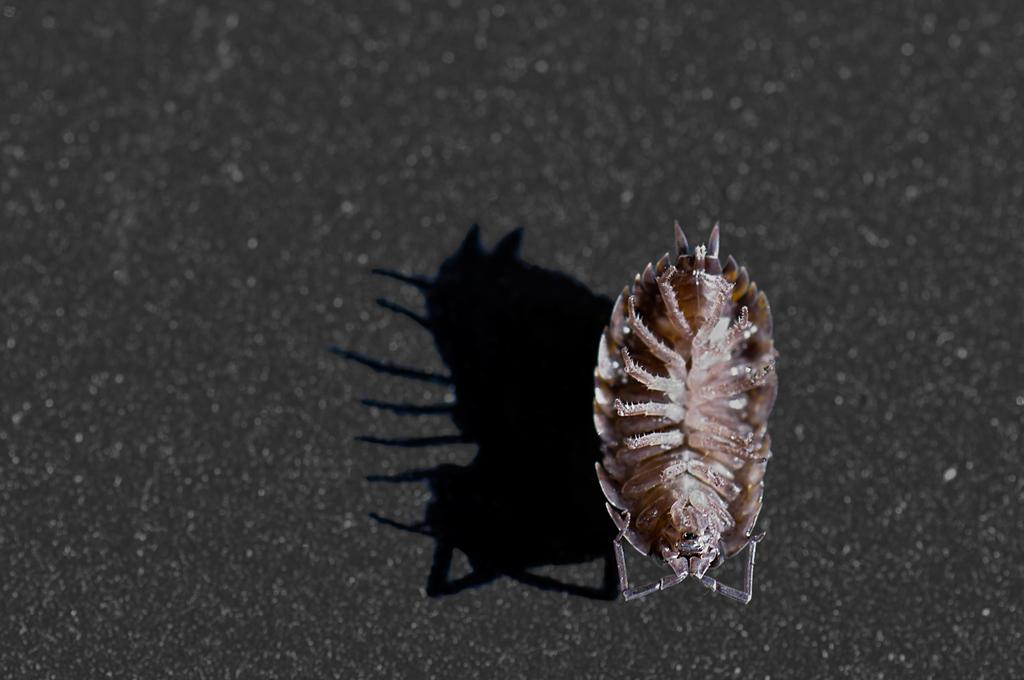What type of creature is present in the image? There is an insect in the image. What can be seen in relation to the insect's position on the road? The insect's shadow is visible on the road. What is the color of the insect in the image? The insect is in cream color. What type of condition does the stranger have in the image? There is no stranger present in the image, so it is not possible to determine any condition they might have. 